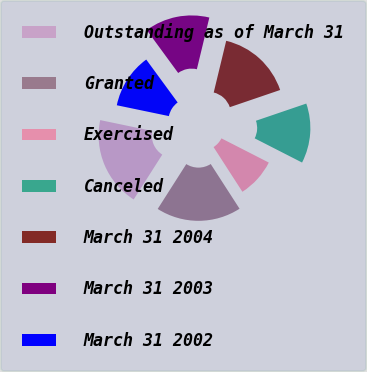Convert chart. <chart><loc_0><loc_0><loc_500><loc_500><pie_chart><fcel>Outstanding as of March 31<fcel>Granted<fcel>Exercised<fcel>Canceled<fcel>March 31 2004<fcel>March 31 2003<fcel>March 31 2002<nl><fcel>19.23%<fcel>18.15%<fcel>8.36%<fcel>12.75%<fcel>15.99%<fcel>13.83%<fcel>11.67%<nl></chart> 